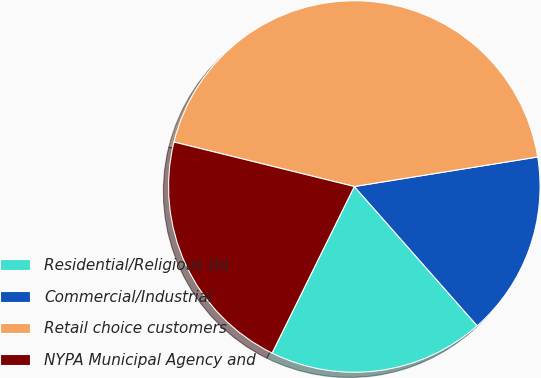Convert chart. <chart><loc_0><loc_0><loc_500><loc_500><pie_chart><fcel>Residential/Religious (b)<fcel>Commercial/Industrial<fcel>Retail choice customers<fcel>NYPA Municipal Agency and<nl><fcel>18.8%<fcel>16.04%<fcel>43.61%<fcel>21.55%<nl></chart> 